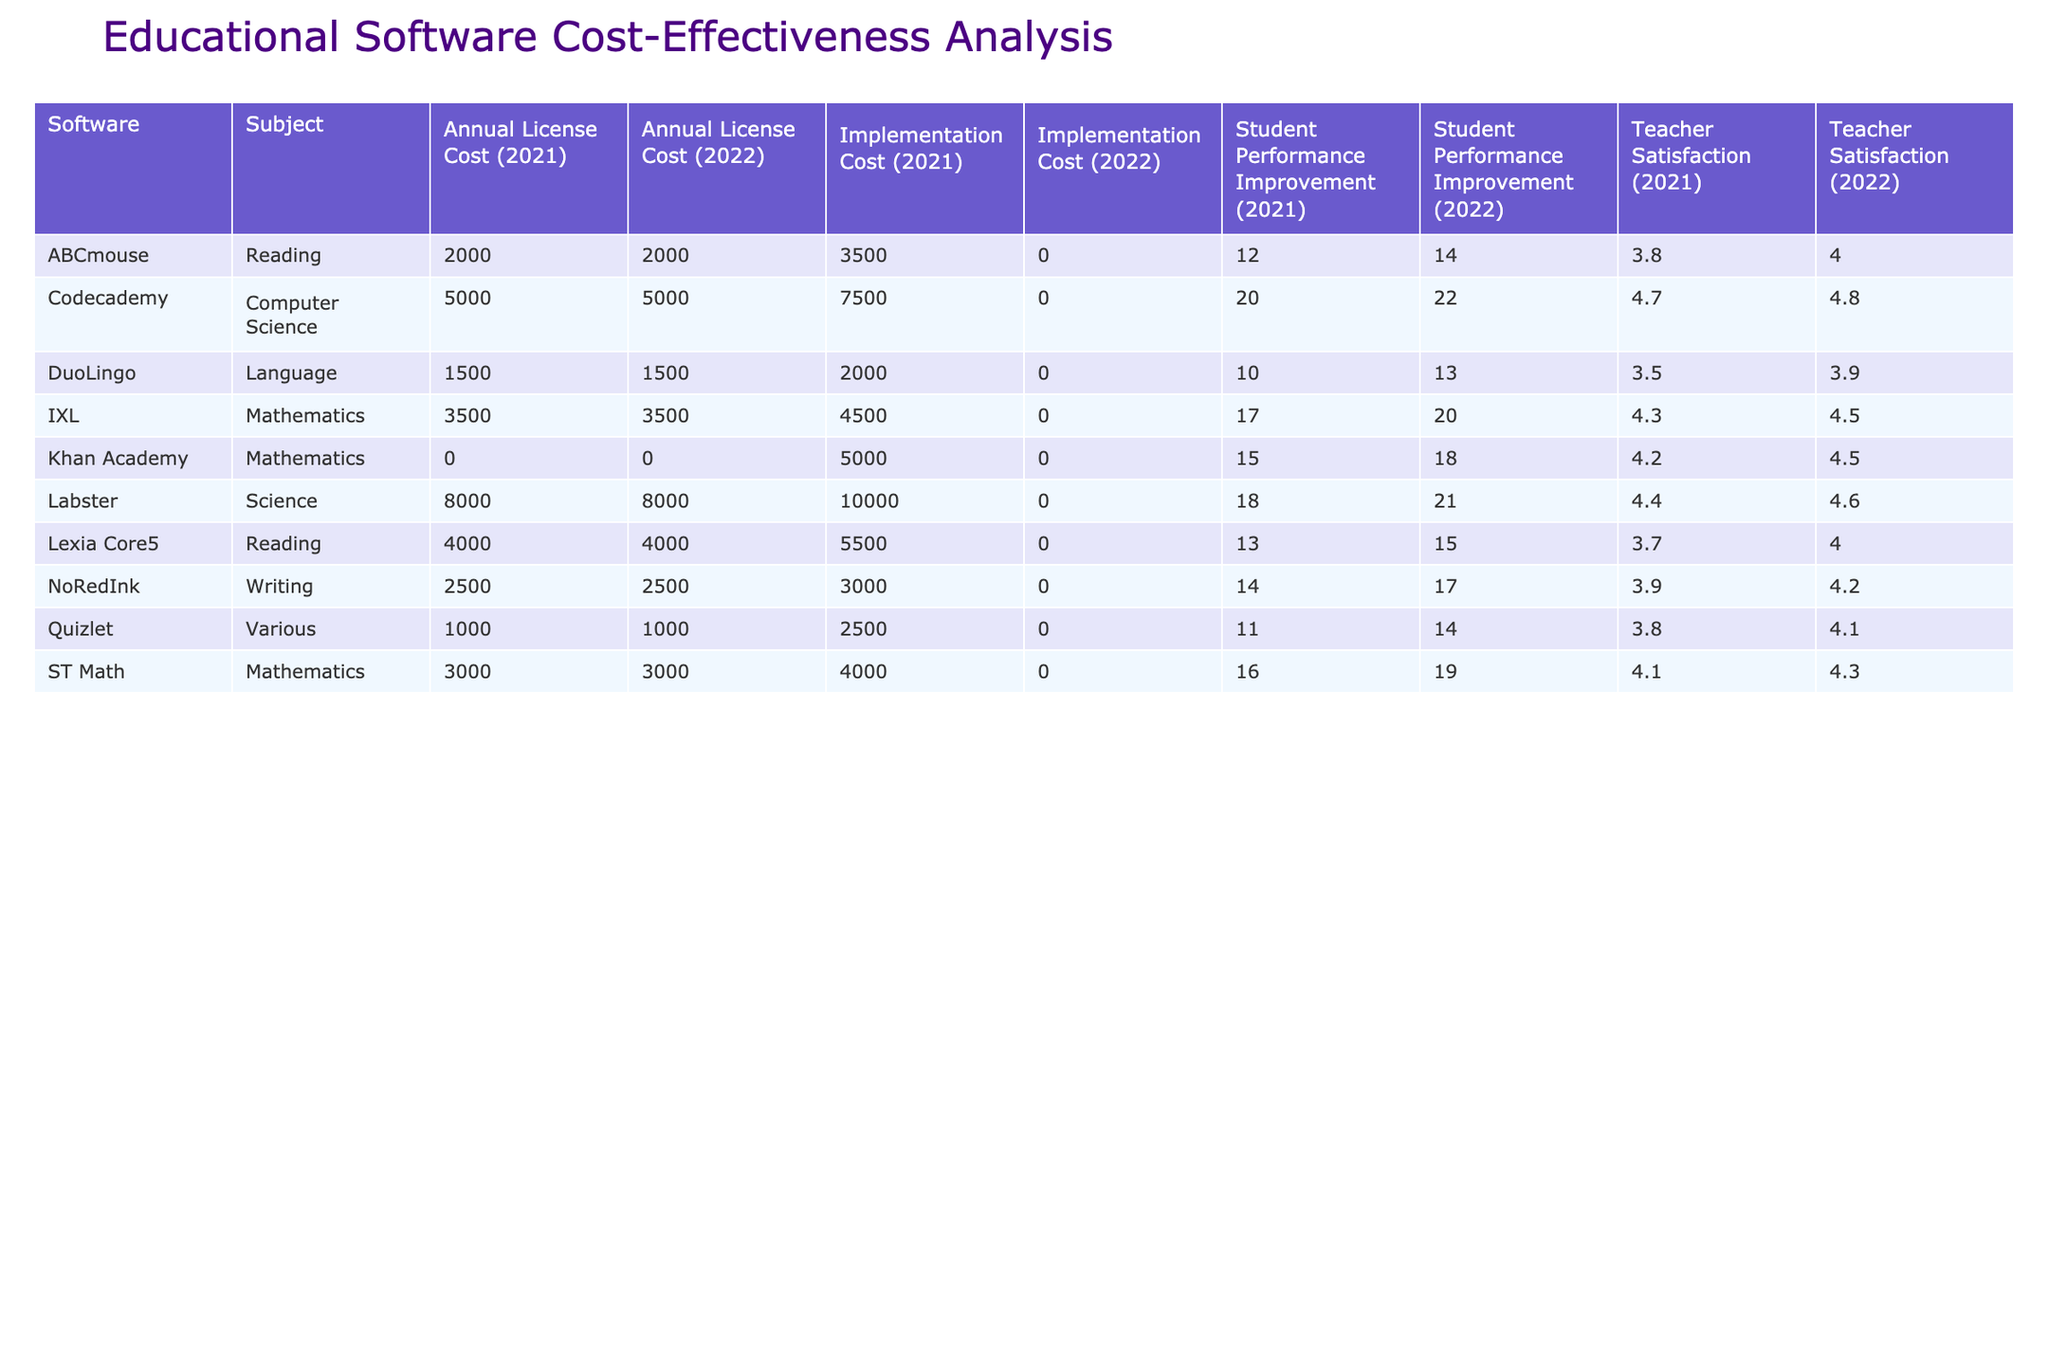What is the implementation cost of Khan Academy in Lincoln High in 2021? The table shows that the implementation cost for Khan Academy in Lincoln High in 2021 is 5000.
Answer: 5000 What was the annual license cost for ABCmouse in Washington Elementary in 2022? The table indicates that the annual license cost for ABCmouse in Washington Elementary in 2022 is 2000.
Answer: 2000 What is the average student performance improvement for DuoLingo across both years at Jefferson Middle? For 2021, the student performance improvement is 10%, and for 2022, it is 13%. To calculate the average, we add them together (10 + 13) = 23 and divide by 2, resulting in 23/2 = 11.5%.
Answer: 11.5% Did Franklin Elementary show an improvement in teacher satisfaction from 2021 to 2022? In 2021, teacher satisfaction for ST Math at Franklin Elementary is 4.1, while in 2022 it increases to 4.3. Hence, teacher satisfaction did improve.
Answer: Yes Which software had the highest teacher satisfaction rating in 2022? From the table, the teacher satisfaction ratings for 2022 are as follows: Khan Academy (4.5), ABCmouse (4.0), DuoLingo (3.9), Codecademy (4.8), ST Math (4.3), NoRedInk (4.2), Labster (4.6), Lexia Core5 (4.0), IXL (4.5), and Quizlet (4.1). The highest rating is for Codecademy at 4.8.
Answer: Codecademy 